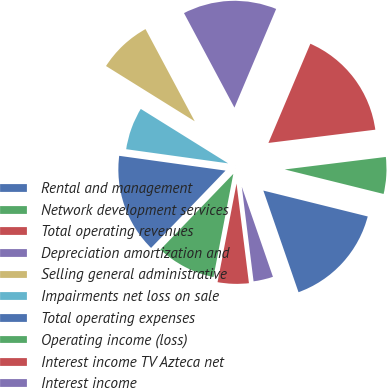<chart> <loc_0><loc_0><loc_500><loc_500><pie_chart><fcel>Rental and management<fcel>Network development services<fcel>Total operating revenues<fcel>Depreciation amortization and<fcel>Selling general administrative<fcel>Impairments net loss on sale<fcel>Total operating expenses<fcel>Operating income (loss)<fcel>Interest income TV Azteca net<fcel>Interest income<nl><fcel>15.83%<fcel>5.83%<fcel>16.67%<fcel>14.17%<fcel>8.33%<fcel>6.67%<fcel>15.0%<fcel>9.17%<fcel>5.0%<fcel>3.33%<nl></chart> 